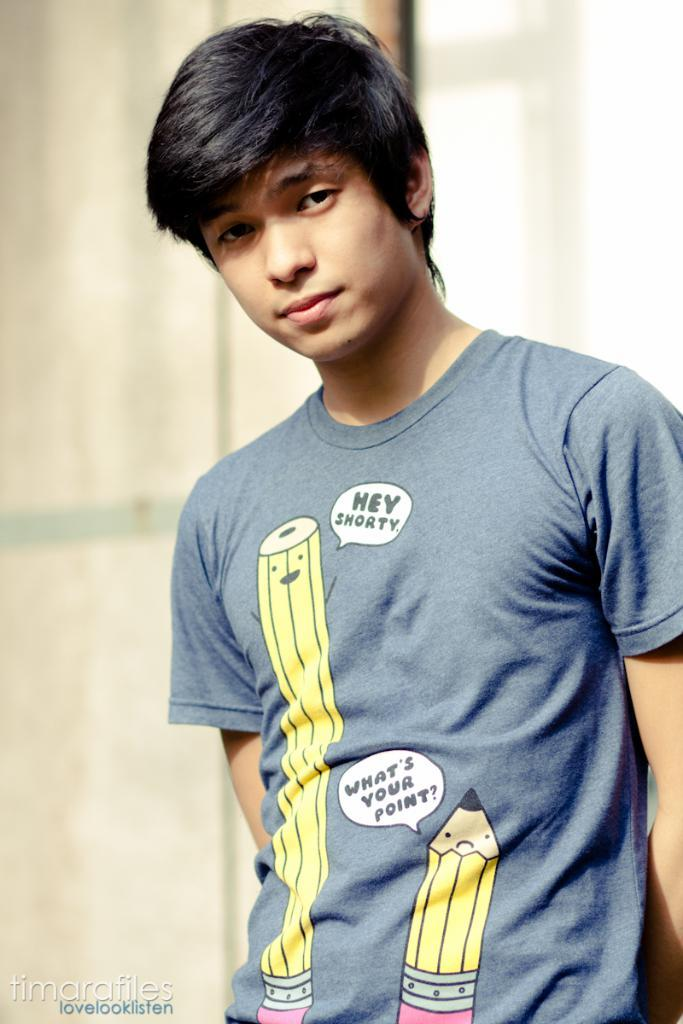<image>
Create a compact narrative representing the image presented. a guy that has a Hey Shorty shirt on his back 